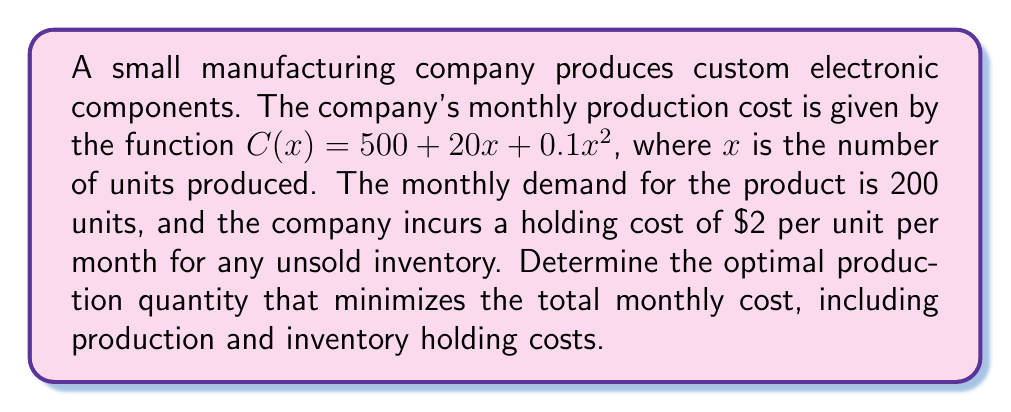Show me your answer to this math problem. To solve this optimization problem, we need to follow these steps:

1) First, let's define our total cost function. It consists of two parts:
   a) Production cost: $C(x) = 500 + 20x + 0.1x^2$
   b) Inventory holding cost: $2(x - 200)$ for $x > 200$, or 0 for $x \leq 200$

   The total cost function is:

   $$T(x) = \begin{cases} 
   500 + 20x + 0.1x^2 & \text{if } x \leq 200 \\
   500 + 20x + 0.1x^2 + 2(x - 200) & \text{if } x > 200
   \end{cases}$$

2) To find the minimum cost, we need to find the value of $x$ where the derivative of $T(x)$ equals zero. However, we have a piecewise function, so we need to consider both cases:

   Case 1: $x \leq 200$
   $$\frac{d}{dx}T(x) = 20 + 0.2x$$
   Setting this equal to zero:
   $$20 + 0.2x = 0$$
   $$0.2x = -20$$
   $$x = -100$$

   This solution is not valid as it's negative and we can't produce a negative quantity.

   Case 2: $x > 200$
   $$\frac{d}{dx}T(x) = 20 + 0.2x + 2 = 22 + 0.2x$$
   Setting this equal to zero:
   $$22 + 0.2x = 0$$
   $$0.2x = -22$$
   $$x = -110$$

   This solution is also not valid for the same reason.

3) Since neither solution is valid, the minimum must occur at the boundary between the two pieces of our function, which is at $x = 200$.

4) To confirm this, we can check the values of $T(x)$ just before and after $x = 200$:

   At $x = 199$: $T(199) = 500 + 20(199) + 0.1(199)^2 = 8,460.1$
   At $x = 200$: $T(200) = 500 + 20(200) + 0.1(200)^2 = 8,500$
   At $x = 201$: $T(201) = 500 + 20(201) + 0.1(201)^2 + 2(1) = 8,542.1$

   We can see that $T(200)$ is indeed the minimum.

Therefore, the optimal production quantity is 200 units, which exactly meets the monthly demand and minimizes the total monthly cost.
Answer: The optimal production quantity is 200 units. 